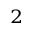Convert formula to latex. <formula><loc_0><loc_0><loc_500><loc_500>_ { 2 }</formula> 